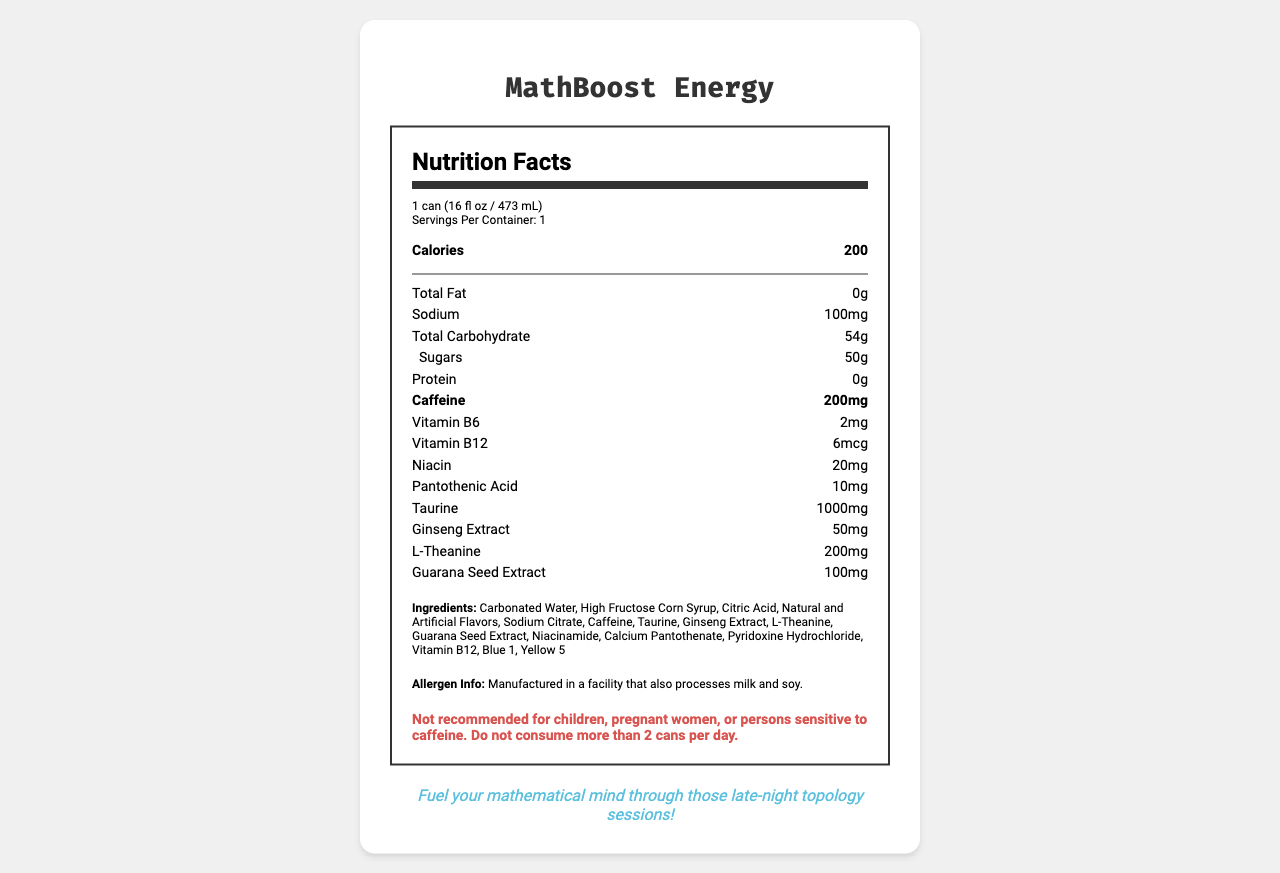what is the serving size of MathBoost Energy? The serving size is mentioned at the top of the nutrition label under the serving information section.
Answer: 1 can (16 fl oz / 473 mL) how many calories are there in one serving of MathBoost Energy? The number of calories per serving is prominently listed under the "Calories" section on the label.
Answer: 200 how much sodium is present per serving? The amount of sodium is specified under the nutrient breakdown section on the label.
Answer: 100mg what is the caffeine content in each can of MathBoost Energy? The caffeine content is highlighted in bold in the nutrient section.
Answer: 200mg what is the warning associated with MathBoost Energy? The warning is explicitly stated in the warning section at the bottom of the label.
Answer: Not recommended for children, pregnant women, or persons sensitive to caffeine. Do not consume more than 2 cans per day. which vitamin is present in the largest quantity? A. Vitamin B6 B. Vitamin B12 C. Niacin Niacin is present in the largest quantity of 20mg, compared to 2mg of Vitamin B6 and 6mcg of Vitamin B12.
Answer: C. Niacin what nootropic ingredients are included in MathBoost Energy? The nootropic ingredients are listed in both the nutrient section and the ingredients list.
Answer: Taurine, Ginseng Extract, L-Theanine, Guarana Seed Extract is MathBoost Energy suitable for children to consume? The warning clearly states "Not recommended for children."
Answer: No describe the marketing tagline for MathBoost Energy. The marketing tagline encourages math students to use this drink for late-night study sessions.
Answer: Fuel your mathematical mind through those late-night topology sessions! what is the main purpose of MathBoost Energy as described in the product description? The product description emphasizes the drink's role in improving focus and mental clarity for mathematics students.
Answer: Helps sharpen your focus and mental clarity during study hours. how many grams of sugar are there per serving? The amount of sugar is listed under the "Total Carbohydrate" section.
Answer: 50g what are the main ingredients of MathBoost Energy? The ingredients are listed towards the bottom of the label.
Answer: Carbonated Water, High Fructose Corn Syrup, Citric Acid, Natural and Artificial Flavors, Sodium Citrate, Caffeine, Taurine, Ginseng Extract, L-Theanine, Guarana Seed Extract, Niacinamide, Calcium Pantothenate, Pyridoxine Hydrochloride, Vitamin B12, Blue 1, Yellow 5 how many servings are there per container? The number of servings per container is specified in the serving information section.
Answer: 1 is MathBoost Energy recommended for pregnant women? The warning section advises against consumption by pregnant women.
Answer: No how much protein is in MathBoost Energy? The protein content is listed as 0g in the nutrient section.
Answer: 0g how many milligrams of taurine does each can contain? The amount of taurine is explicitly listed in the nutrient section.
Answer: 1000mg what are the colors used in MathBoost Energy? The colors are listed at the end of the ingredients.
Answer: Blue 1, Yellow 5 what essential vitamin is not listed in the nutrition facts section? The document does not provide enough information to determine which essential vitamins are not listed.
Answer: I don't know how much vitamin B6 is in each can? The vitamin B6 content is listed in the nutrient section.
Answer: 2mg what is the main idea of the entire document? The main idea encompasses the product's nutrition facts, ingredients, and its targeted purpose for improving focus and clarity for mathematics students.
Answer: The document provides detailed nutrition facts and ingredient information about MathBoost Energy, a caffeine-rich energy drink designed to help mathematics graduate students with focus and mental clarity during late-night study sessions. It contains a variety of vitamins, nootropics, and a high amount of caffeine. 